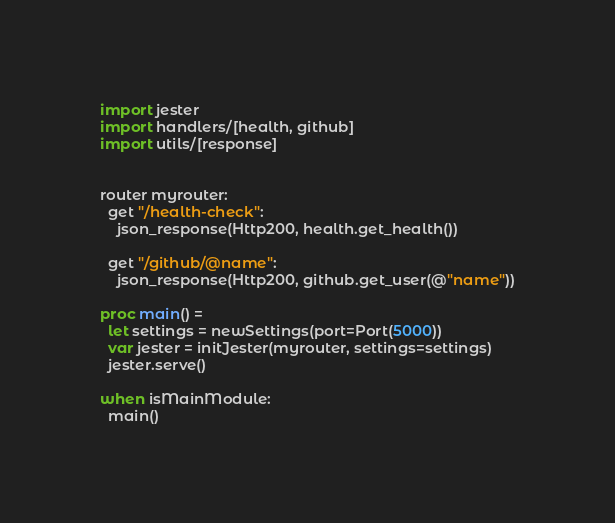Convert code to text. <code><loc_0><loc_0><loc_500><loc_500><_Nim_>import jester
import handlers/[health, github]
import utils/[response]


router myrouter:
  get "/health-check":
    json_response(Http200, health.get_health())

  get "/github/@name":
    json_response(Http200, github.get_user(@"name"))

proc main() =
  let settings = newSettings(port=Port(5000))
  var jester = initJester(myrouter, settings=settings)
  jester.serve()

when isMainModule:
  main()</code> 